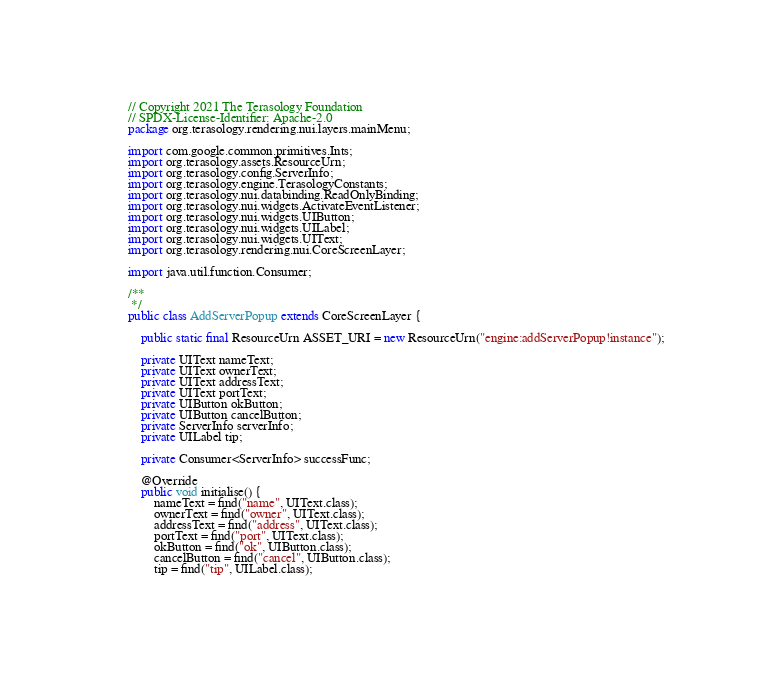<code> <loc_0><loc_0><loc_500><loc_500><_Java_>// Copyright 2021 The Terasology Foundation
// SPDX-License-Identifier: Apache-2.0
package org.terasology.rendering.nui.layers.mainMenu;

import com.google.common.primitives.Ints;
import org.terasology.assets.ResourceUrn;
import org.terasology.config.ServerInfo;
import org.terasology.engine.TerasologyConstants;
import org.terasology.nui.databinding.ReadOnlyBinding;
import org.terasology.nui.widgets.ActivateEventListener;
import org.terasology.nui.widgets.UIButton;
import org.terasology.nui.widgets.UILabel;
import org.terasology.nui.widgets.UIText;
import org.terasology.rendering.nui.CoreScreenLayer;

import java.util.function.Consumer;

/**
 */
public class AddServerPopup extends CoreScreenLayer {

    public static final ResourceUrn ASSET_URI = new ResourceUrn("engine:addServerPopup!instance");

    private UIText nameText;
    private UIText ownerText;
    private UIText addressText;
    private UIText portText;
    private UIButton okButton;
    private UIButton cancelButton;
    private ServerInfo serverInfo;
    private UILabel tip;

    private Consumer<ServerInfo> successFunc;

    @Override
    public void initialise() {
        nameText = find("name", UIText.class);
        ownerText = find("owner", UIText.class);
        addressText = find("address", UIText.class);
        portText = find("port", UIText.class);
        okButton = find("ok", UIButton.class);
        cancelButton = find("cancel", UIButton.class);
        tip = find("tip", UILabel.class);
</code> 